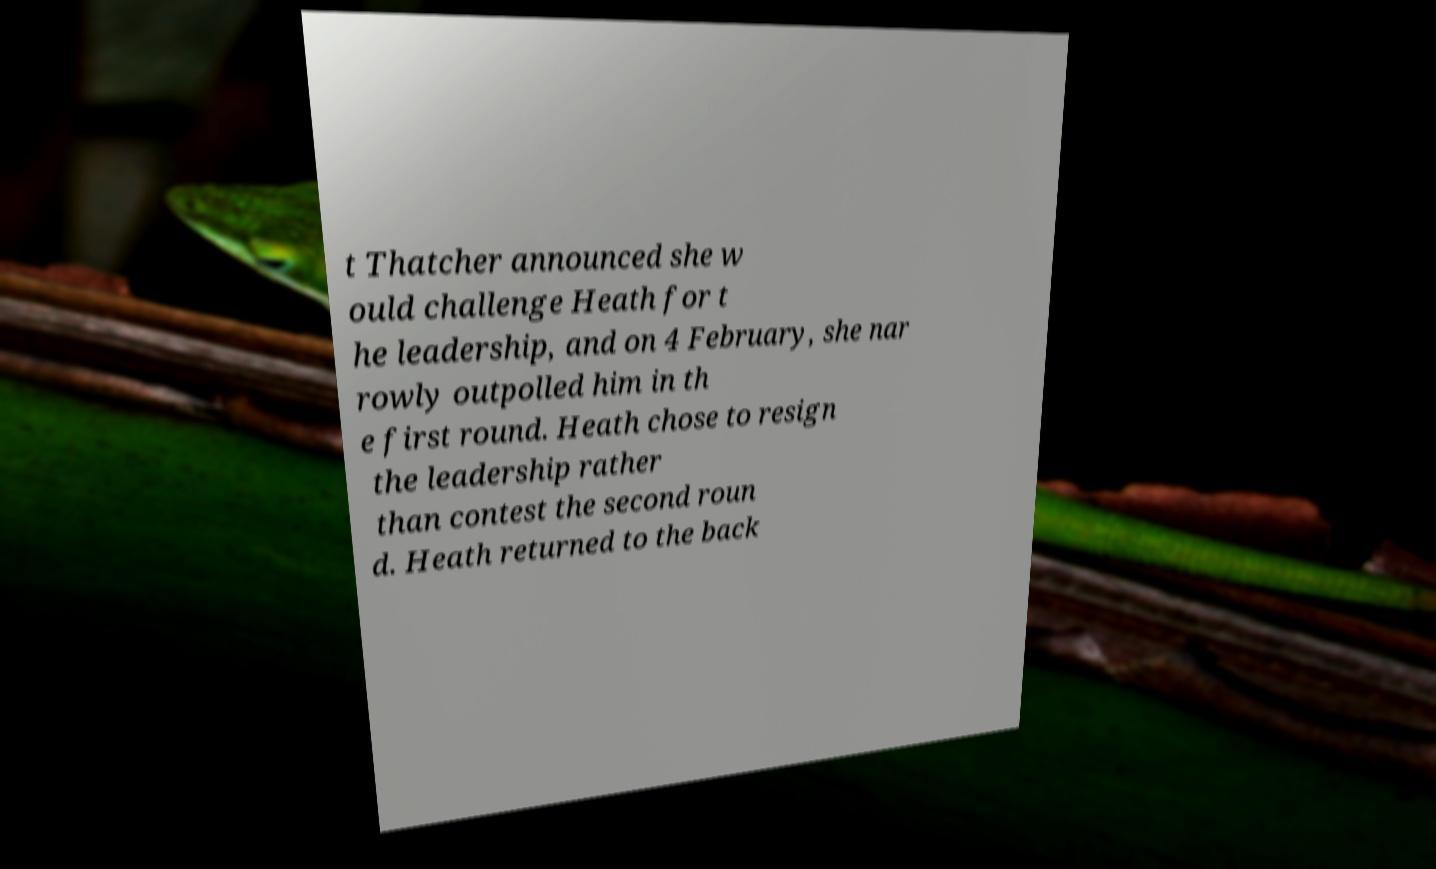Please read and relay the text visible in this image. What does it say? t Thatcher announced she w ould challenge Heath for t he leadership, and on 4 February, she nar rowly outpolled him in th e first round. Heath chose to resign the leadership rather than contest the second roun d. Heath returned to the back 